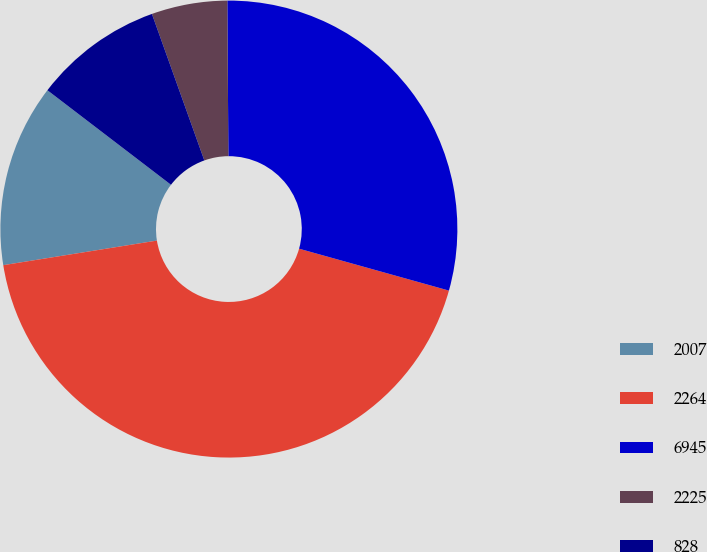Convert chart. <chart><loc_0><loc_0><loc_500><loc_500><pie_chart><fcel>2007<fcel>2264<fcel>6945<fcel>2225<fcel>828<nl><fcel>12.92%<fcel>43.14%<fcel>29.45%<fcel>5.36%<fcel>9.14%<nl></chart> 